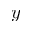Convert formula to latex. <formula><loc_0><loc_0><loc_500><loc_500>y</formula> 